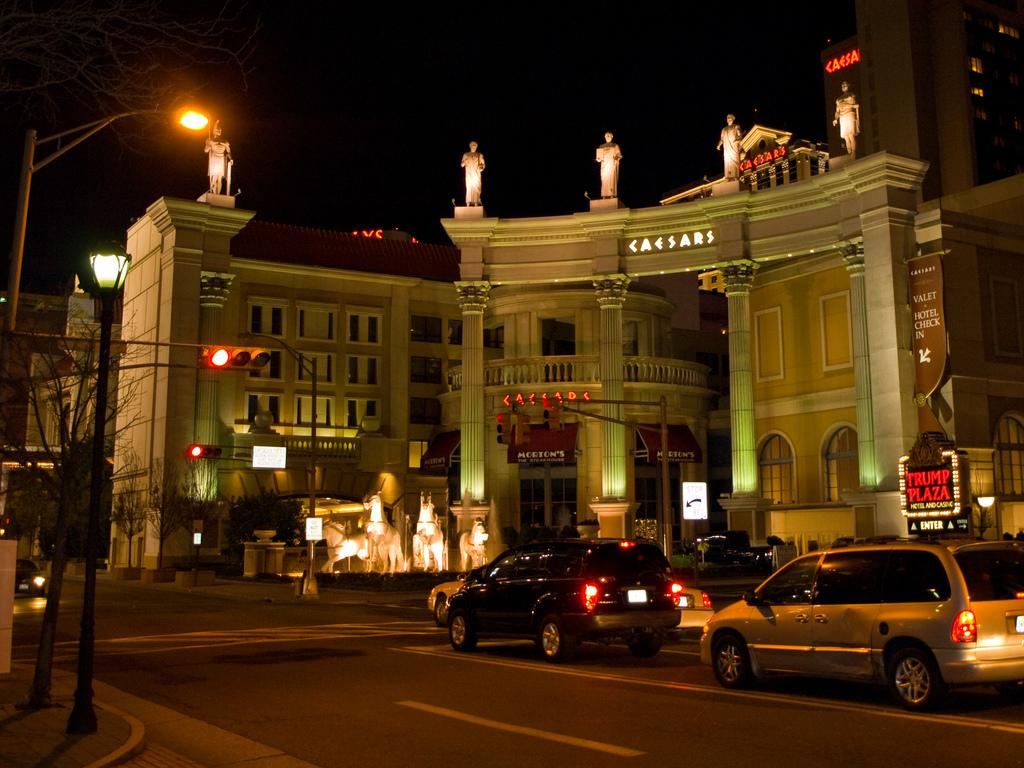<image>
Give a short and clear explanation of the subsequent image. The Caesars building which includes a Morton's Steakhouse restaurant 